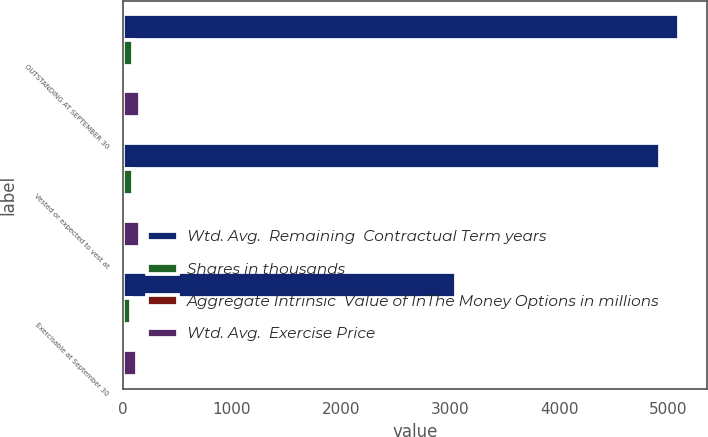Convert chart to OTSL. <chart><loc_0><loc_0><loc_500><loc_500><stacked_bar_chart><ecel><fcel>OUTSTANDING AT SEPTEMBER 30<fcel>Vested or expected to vest at<fcel>Exercisable at September 30<nl><fcel>Wtd. Avg.  Remaining  Contractual Term years<fcel>5098<fcel>4918<fcel>3049<nl><fcel>Shares in thousands<fcel>90.96<fcel>90.31<fcel>79.15<nl><fcel>Aggregate Intrinsic  Value of InThe Money Options in millions<fcel>6.7<fcel>6.6<fcel>5.4<nl><fcel>Wtd. Avg.  Exercise Price<fcel>160<fcel>157.5<fcel>131.7<nl></chart> 